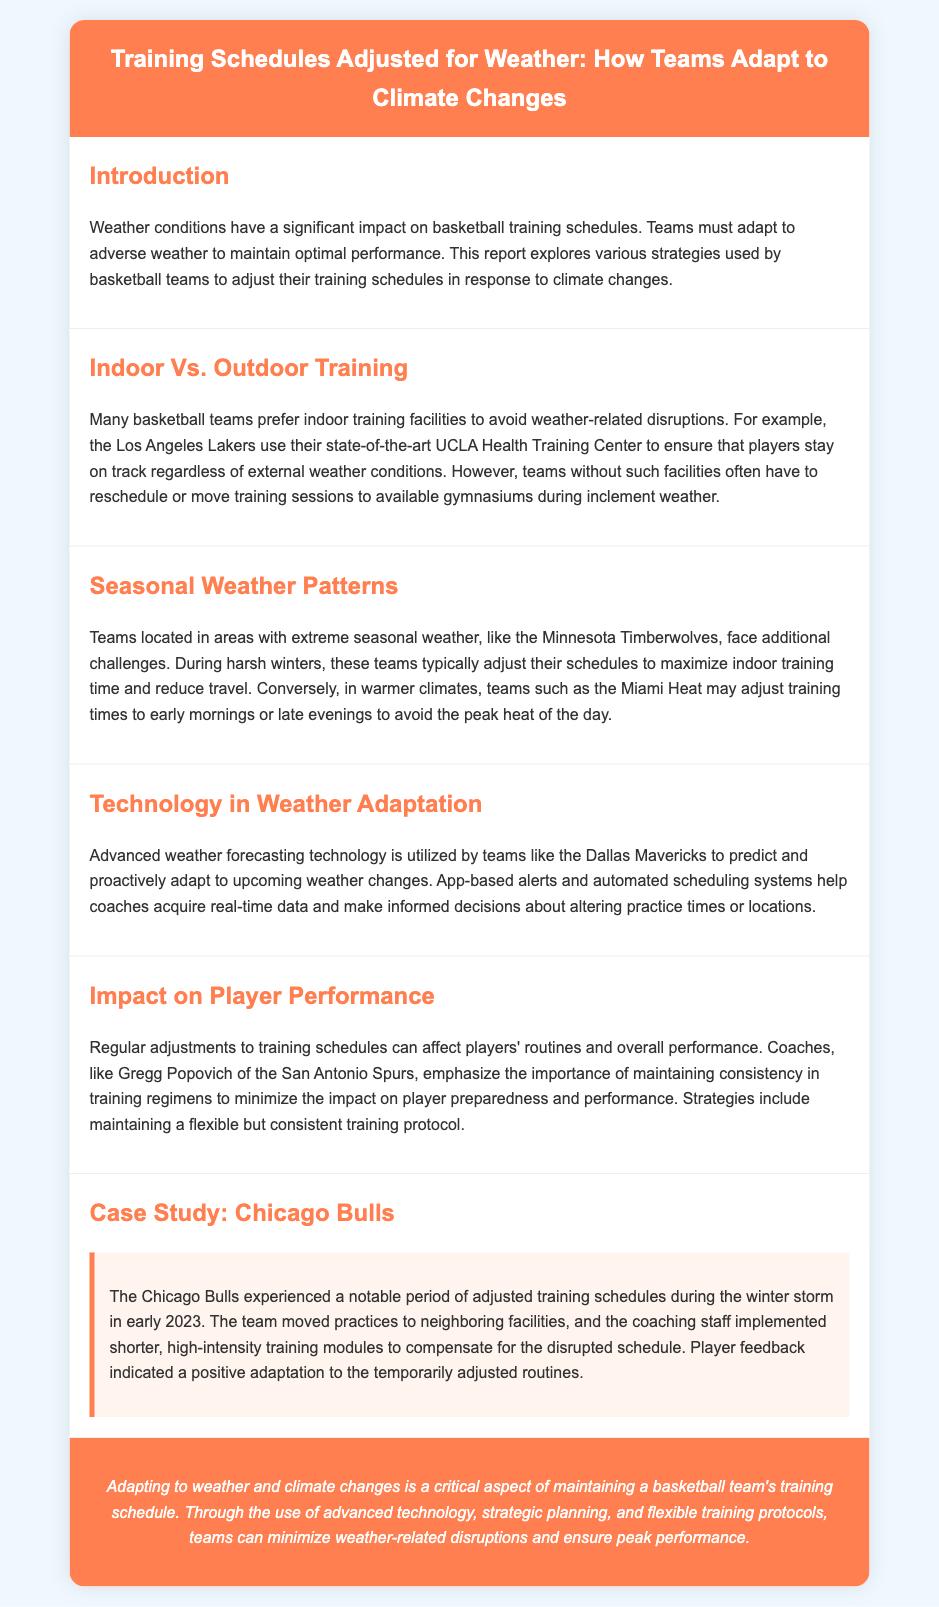What is the title of the report? The title of the report is stated in the header section of the document.
Answer: Training Schedules Adjusted for Weather: How Teams Adapt to Climate Changes Which team uses the UCLA Health Training Center? The document mentions the Los Angeles Lakers utilizing this facility for training.
Answer: Los Angeles Lakers What technology do the Dallas Mavericks use for weather adaptation? The text highlights that advanced weather forecasting technology is employed by the Dallas Mavericks.
Answer: Advanced weather forecasting technology What type of training does the Chicago Bulls implement during adjusted schedules? A specific training approach highlighted in the case study section is described.
Answer: Shorter, high-intensity training modules What weather pattern do the Minnesota Timberwolves adjust their training for? The document describes how the Minnesota Timberwolves deal with specific harsh weather conditions.
Answer: Harsh winters 